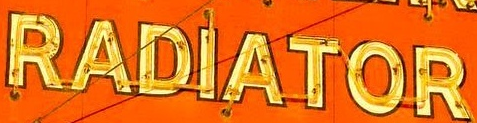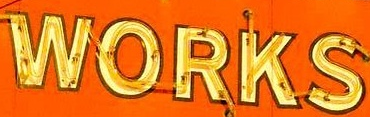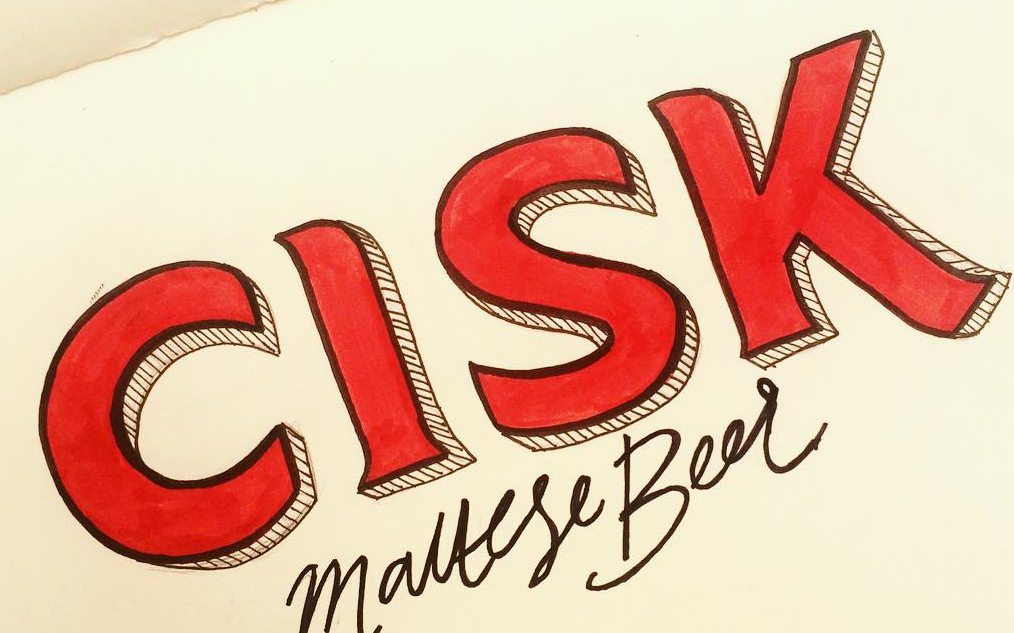Read the text from these images in sequence, separated by a semicolon. RADIATOR; WORKS; CISK 